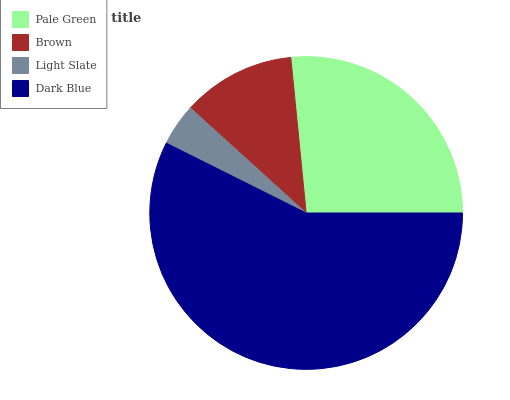Is Light Slate the minimum?
Answer yes or no. Yes. Is Dark Blue the maximum?
Answer yes or no. Yes. Is Brown the minimum?
Answer yes or no. No. Is Brown the maximum?
Answer yes or no. No. Is Pale Green greater than Brown?
Answer yes or no. Yes. Is Brown less than Pale Green?
Answer yes or no. Yes. Is Brown greater than Pale Green?
Answer yes or no. No. Is Pale Green less than Brown?
Answer yes or no. No. Is Pale Green the high median?
Answer yes or no. Yes. Is Brown the low median?
Answer yes or no. Yes. Is Brown the high median?
Answer yes or no. No. Is Pale Green the low median?
Answer yes or no. No. 